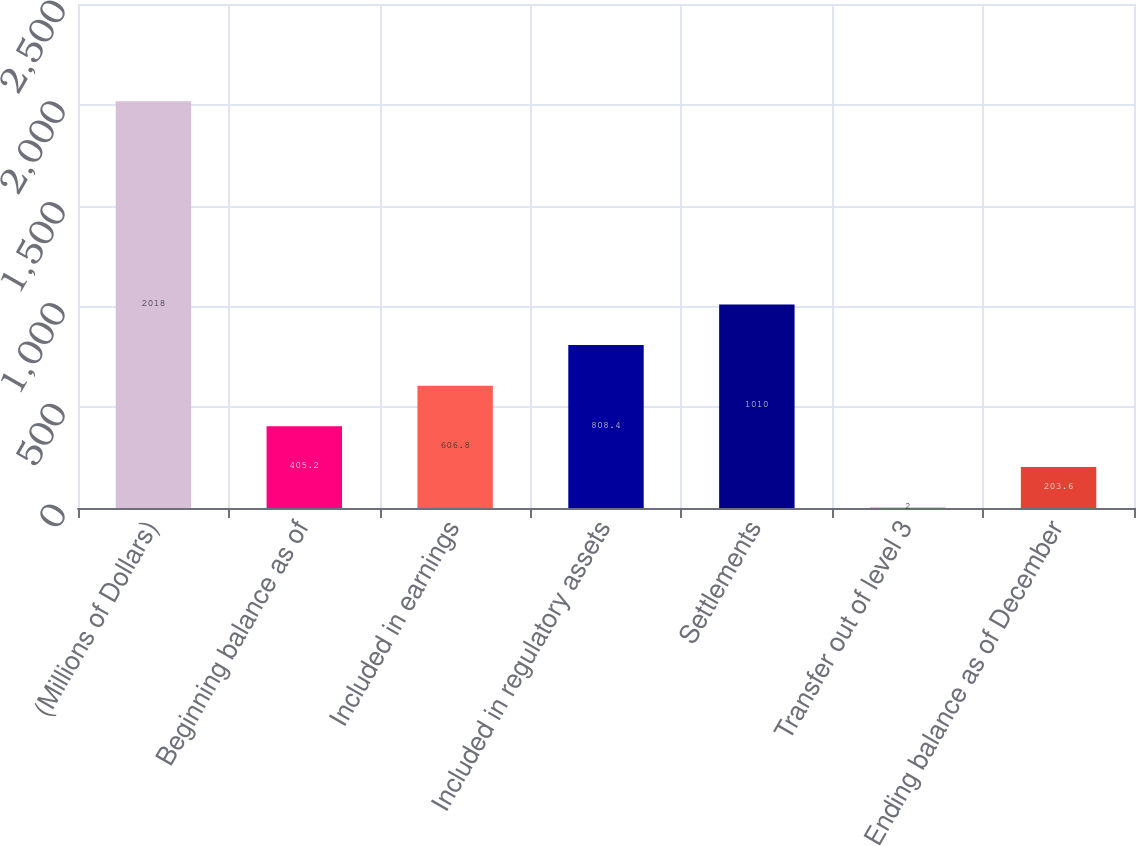Convert chart. <chart><loc_0><loc_0><loc_500><loc_500><bar_chart><fcel>(Millions of Dollars)<fcel>Beginning balance as of<fcel>Included in earnings<fcel>Included in regulatory assets<fcel>Settlements<fcel>Transfer out of level 3<fcel>Ending balance as of December<nl><fcel>2018<fcel>405.2<fcel>606.8<fcel>808.4<fcel>1010<fcel>2<fcel>203.6<nl></chart> 